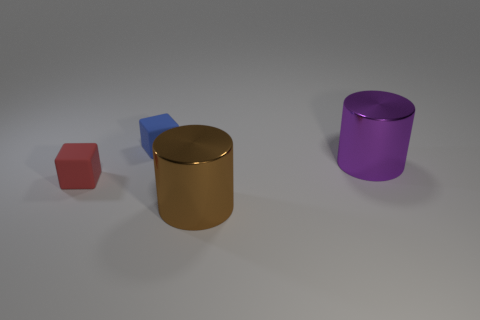Are there fewer purple metallic objects that are behind the small blue thing than large shiny things on the left side of the big brown object?
Offer a very short reply. No. What number of things are either gray rubber cubes or cylinders?
Keep it short and to the point. 2. There is a large brown cylinder; how many small blue things are behind it?
Provide a short and direct response. 1. What is the shape of the other thing that is the same material as the blue thing?
Make the answer very short. Cube. There is a small red object that is to the left of the blue block; is it the same shape as the blue object?
Your response must be concise. Yes. How many red objects are either small matte blocks or cylinders?
Keep it short and to the point. 1. Is the number of big purple metal cylinders that are in front of the purple object the same as the number of red matte cubes that are on the right side of the big brown metallic cylinder?
Provide a succinct answer. Yes. What color is the metallic cylinder right of the cylinder that is on the left side of the large cylinder that is on the right side of the brown thing?
Ensure brevity in your answer.  Purple. There is a purple cylinder that is in front of the blue rubber block; how big is it?
Your answer should be compact. Large. There is a thing that is the same size as the brown metallic cylinder; what shape is it?
Provide a succinct answer. Cylinder. 